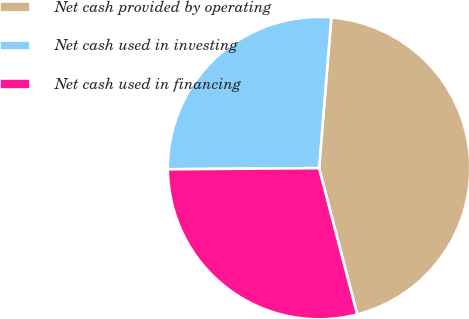Convert chart. <chart><loc_0><loc_0><loc_500><loc_500><pie_chart><fcel>Net cash provided by operating<fcel>Net cash used in investing<fcel>Net cash used in financing<nl><fcel>44.65%<fcel>26.41%<fcel>28.94%<nl></chart> 